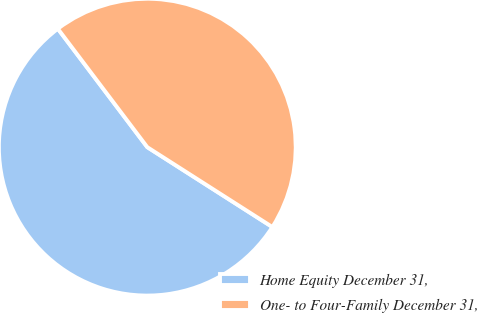Convert chart to OTSL. <chart><loc_0><loc_0><loc_500><loc_500><pie_chart><fcel>Home Equity December 31,<fcel>One- to Four-Family December 31,<nl><fcel>55.66%<fcel>44.34%<nl></chart> 